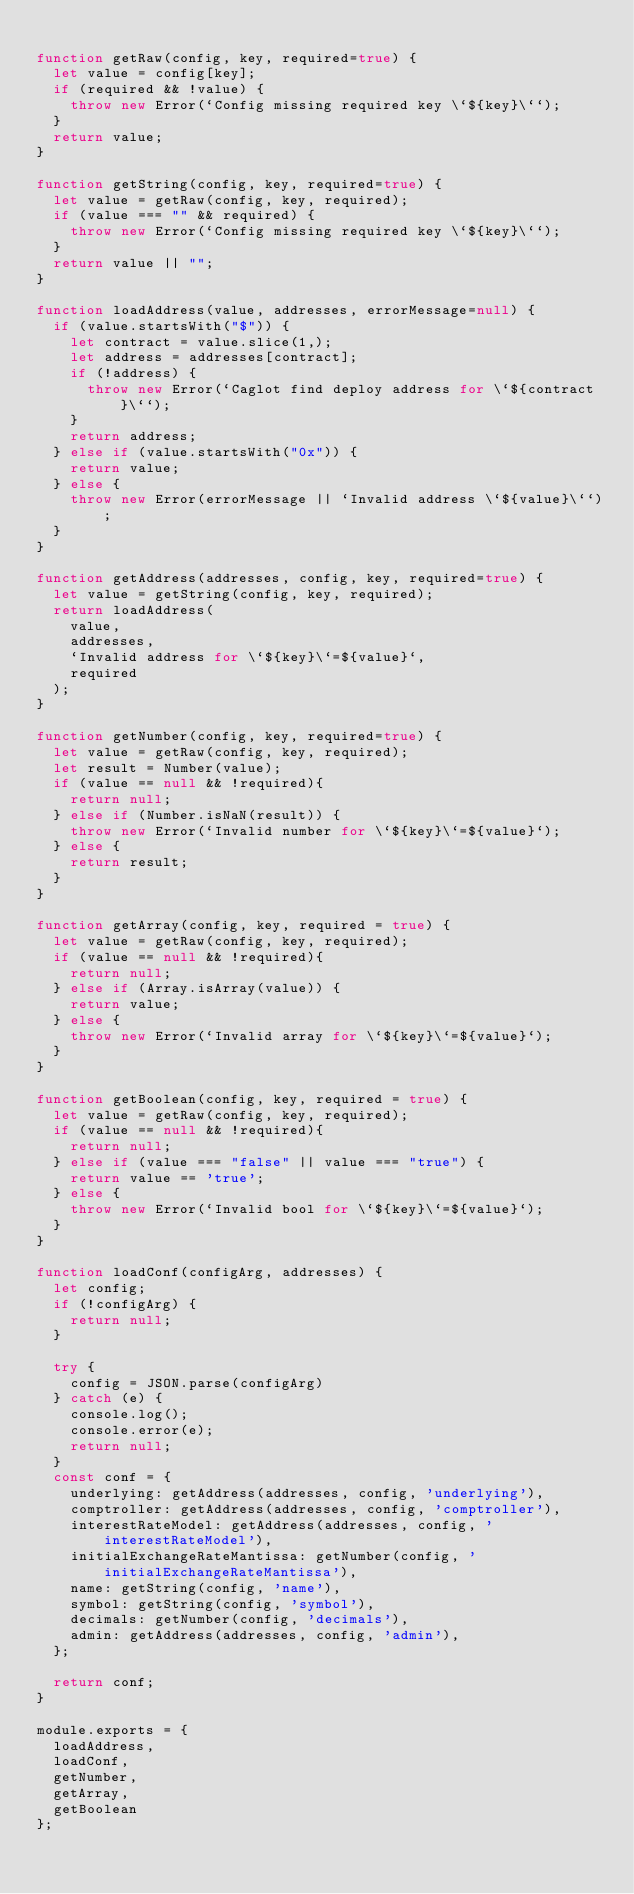<code> <loc_0><loc_0><loc_500><loc_500><_JavaScript_>
function getRaw(config, key, required=true) {
  let value = config[key];
  if (required && !value) {
    throw new Error(`Config missing required key \`${key}\``);
  }
  return value;
}

function getString(config, key, required=true) {
  let value = getRaw(config, key, required);
  if (value === "" && required) {
    throw new Error(`Config missing required key \`${key}\``);
  }
  return value || "";
}

function loadAddress(value, addresses, errorMessage=null) {
  if (value.startsWith("$")) {
    let contract = value.slice(1,);
    let address = addresses[contract];
    if (!address) {
      throw new Error(`Caglot find deploy address for \`${contract}\``);
    }
    return address;
  } else if (value.startsWith("0x")) {
    return value;
  } else {
    throw new Error(errorMessage || `Invalid address \`${value}\``);
  }
}

function getAddress(addresses, config, key, required=true) {
  let value = getString(config, key, required);
  return loadAddress(
    value,
    addresses,
    `Invalid address for \`${key}\`=${value}`,
    required
  );
}

function getNumber(config, key, required=true) {
  let value = getRaw(config, key, required);
  let result = Number(value);
  if (value == null && !required){
    return null;
  } else if (Number.isNaN(result)) {
    throw new Error(`Invalid number for \`${key}\`=${value}`);
  } else {
    return result;
  }
}

function getArray(config, key, required = true) {
  let value = getRaw(config, key, required);
  if (value == null && !required){
    return null;
  } else if (Array.isArray(value)) {
    return value;
  } else {
    throw new Error(`Invalid array for \`${key}\`=${value}`);
  }
}

function getBoolean(config, key, required = true) {
  let value = getRaw(config, key, required);
  if (value == null && !required){
    return null;
  } else if (value === "false" || value === "true") {
    return value == 'true';
  } else {
    throw new Error(`Invalid bool for \`${key}\`=${value}`);
  }
}

function loadConf(configArg, addresses) {
  let config;
  if (!configArg) {
    return null;
  }

  try {
    config = JSON.parse(configArg)
  } catch (e) {
    console.log();
    console.error(e);
    return null;
  }
  const conf = {
    underlying: getAddress(addresses, config, 'underlying'),
    comptroller: getAddress(addresses, config, 'comptroller'),
    interestRateModel: getAddress(addresses, config, 'interestRateModel'),
    initialExchangeRateMantissa: getNumber(config, 'initialExchangeRateMantissa'),
    name: getString(config, 'name'),
    symbol: getString(config, 'symbol'),
    decimals: getNumber(config, 'decimals'),
    admin: getAddress(addresses, config, 'admin'),
  };

  return conf;
}

module.exports = {
  loadAddress,
  loadConf,
  getNumber,
  getArray,
  getBoolean
};
</code> 